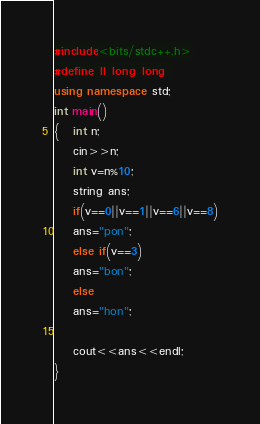<code> <loc_0><loc_0><loc_500><loc_500><_C++_>#include<bits/stdc++.h>
#define ll long long 
using namespace std;
int main()
{   int n;
	cin>>n;
	int v=n%10;
	string ans;
	if(v==0||v==1||v==6||v==8)
	ans="pon";
	else if(v==3)
	ans="bon";
	else 
	ans="hon";
	
	cout<<ans<<endl;
}</code> 